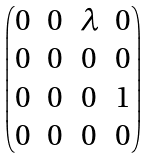Convert formula to latex. <formula><loc_0><loc_0><loc_500><loc_500>\begin{pmatrix} 0 & 0 & \lambda & 0 \\ 0 & 0 & 0 & 0 \\ 0 & 0 & 0 & 1 \\ 0 & 0 & 0 & 0 \end{pmatrix}</formula> 